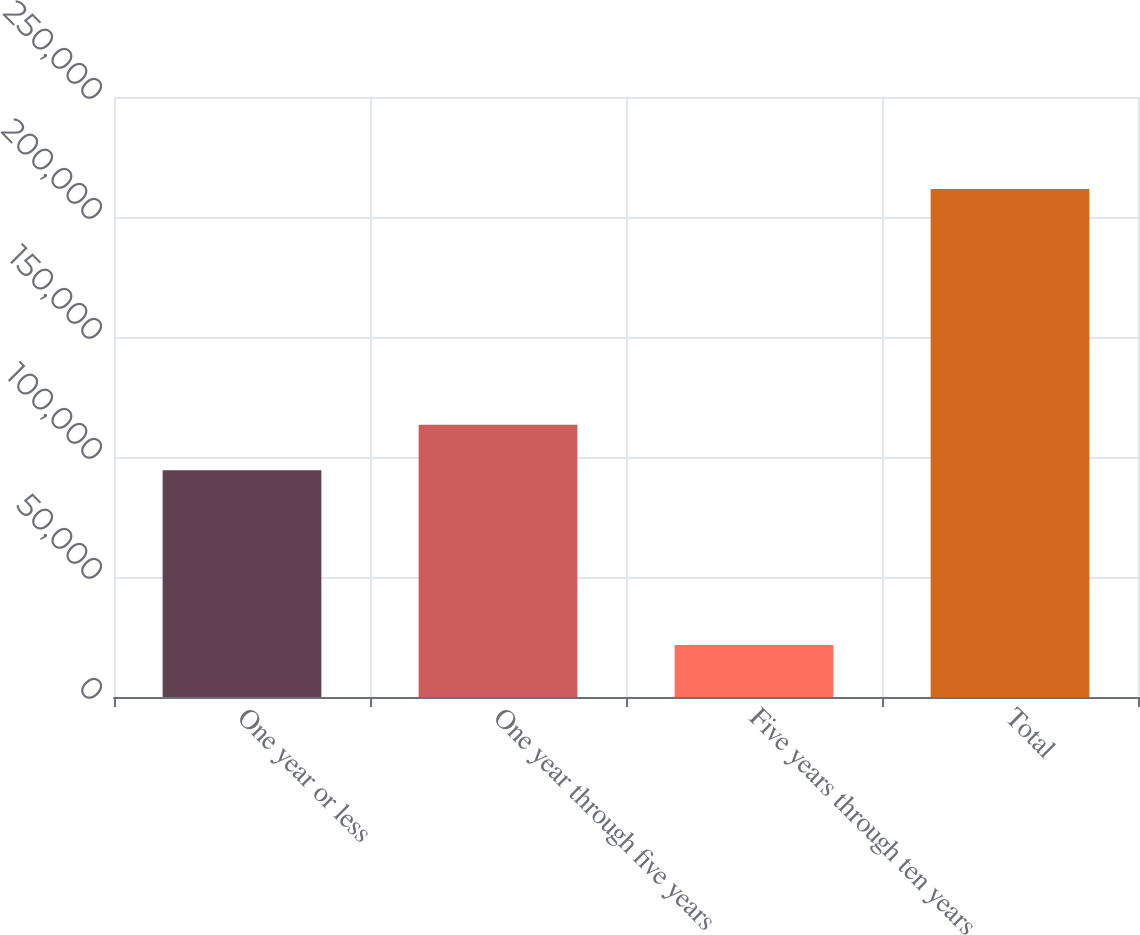Convert chart to OTSL. <chart><loc_0><loc_0><loc_500><loc_500><bar_chart><fcel>One year or less<fcel>One year through five years<fcel>Five years through ten years<fcel>Total<nl><fcel>94442<fcel>113436<fcel>21677<fcel>211619<nl></chart> 